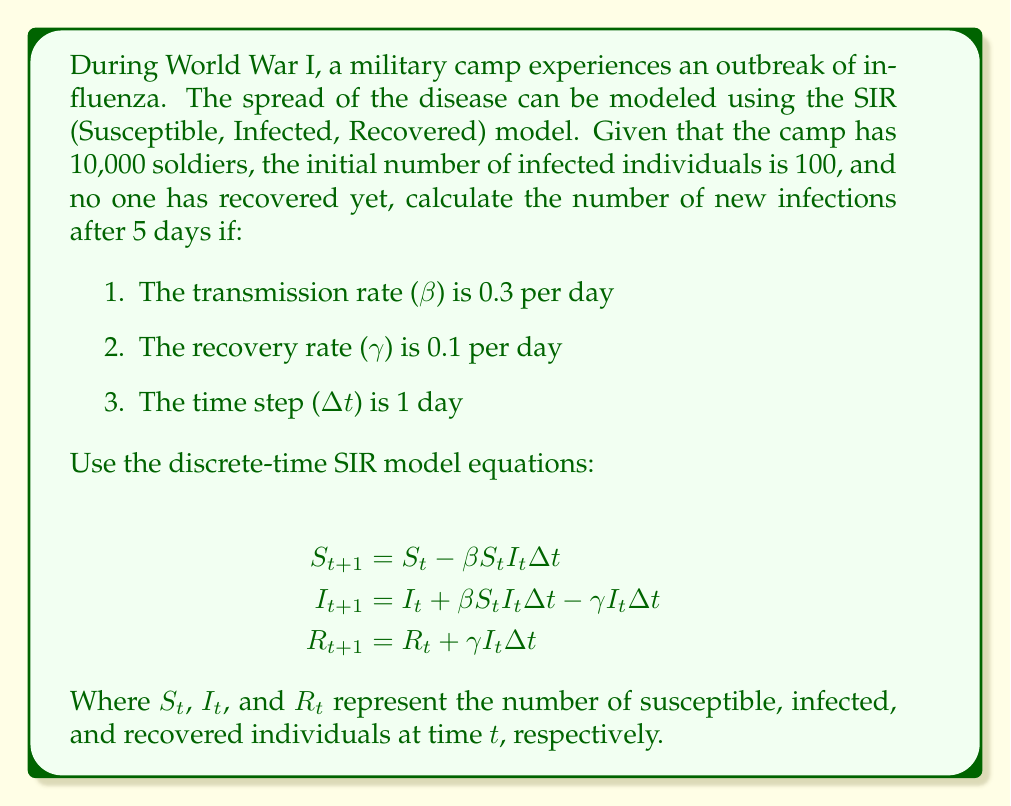Teach me how to tackle this problem. To solve this problem, we need to apply the discrete-time SIR model equations iteratively for 5 days. Let's break it down step by step:

Initial conditions:
$S_0 = 9900$ (Susceptible)
$I_0 = 100$ (Infected)
$R_0 = 0$ (Recovered)

Parameters:
$\beta = 0.3$ (Transmission rate)
$\gamma = 0.1$ (Recovery rate)
$\Delta t = 1$ (Time step)

Step 1: Calculate for Day 1
$$S_1 = S_0 - \beta S_0 I_0 \Delta t = 9900 - 0.3 \times 9900 \times 100 \times 1 = 7030$$
$$I_1 = I_0 + \beta S_0 I_0 \Delta t - \gamma I_0 \Delta t = 100 + 0.3 \times 9900 \times 100 \times 1 - 0.1 \times 100 \times 1 = 2960$$
$$R_1 = R_0 + \gamma I_0 \Delta t = 0 + 0.1 \times 100 \times 1 = 10$$

Step 2: Calculate for Day 2
$$S_2 = 7030 - 0.3 \times 7030 \times 2960 \times 1 = 831.44$$
$$I_2 = 2960 + 0.3 \times 7030 \times 2960 \times 1 - 0.1 \times 2960 \times 1 = 8862.56$$
$$R_2 = 10 + 0.1 \times 2960 \times 1 = 306$$

Step 3: Calculate for Day 3
$$S_3 = 831.44 - 0.3 \times 831.44 \times 8862.56 \times 1 \approx 0$$
$$I_3 = 8862.56 + 0.3 \times 831.44 \times 8862.56 \times 1 - 0.1 \times 8862.56 \times 1 = 9208.74$$
$$R_3 = 306 + 0.1 \times 8862.56 \times 1 = 1192.26$$

Step 4: Calculate for Day 4
$$S_4 \approx 0$$
$$I_4 = 9208.74 - 0.1 \times 9208.74 \times 1 = 8287.87$$
$$R_4 = 1192.26 + 0.1 \times 9208.74 \times 1 = 2113.13$$

Step 5: Calculate for Day 5
$$S_5 \approx 0$$
$$I_5 = 8287.87 - 0.1 \times 8287.87 \times 1 = 7459.08$$
$$R_5 = 2113.13 + 0.1 \times 8287.87 \times 1 = 2941.92$$

To find the number of new infections after 5 days, we subtract the initial number of infected from the final number of infected:

New infections = $I_5 - I_0 = 7459.08 - 100 = 7359.08$
Answer: The number of new infections after 5 days is approximately 7,359. 